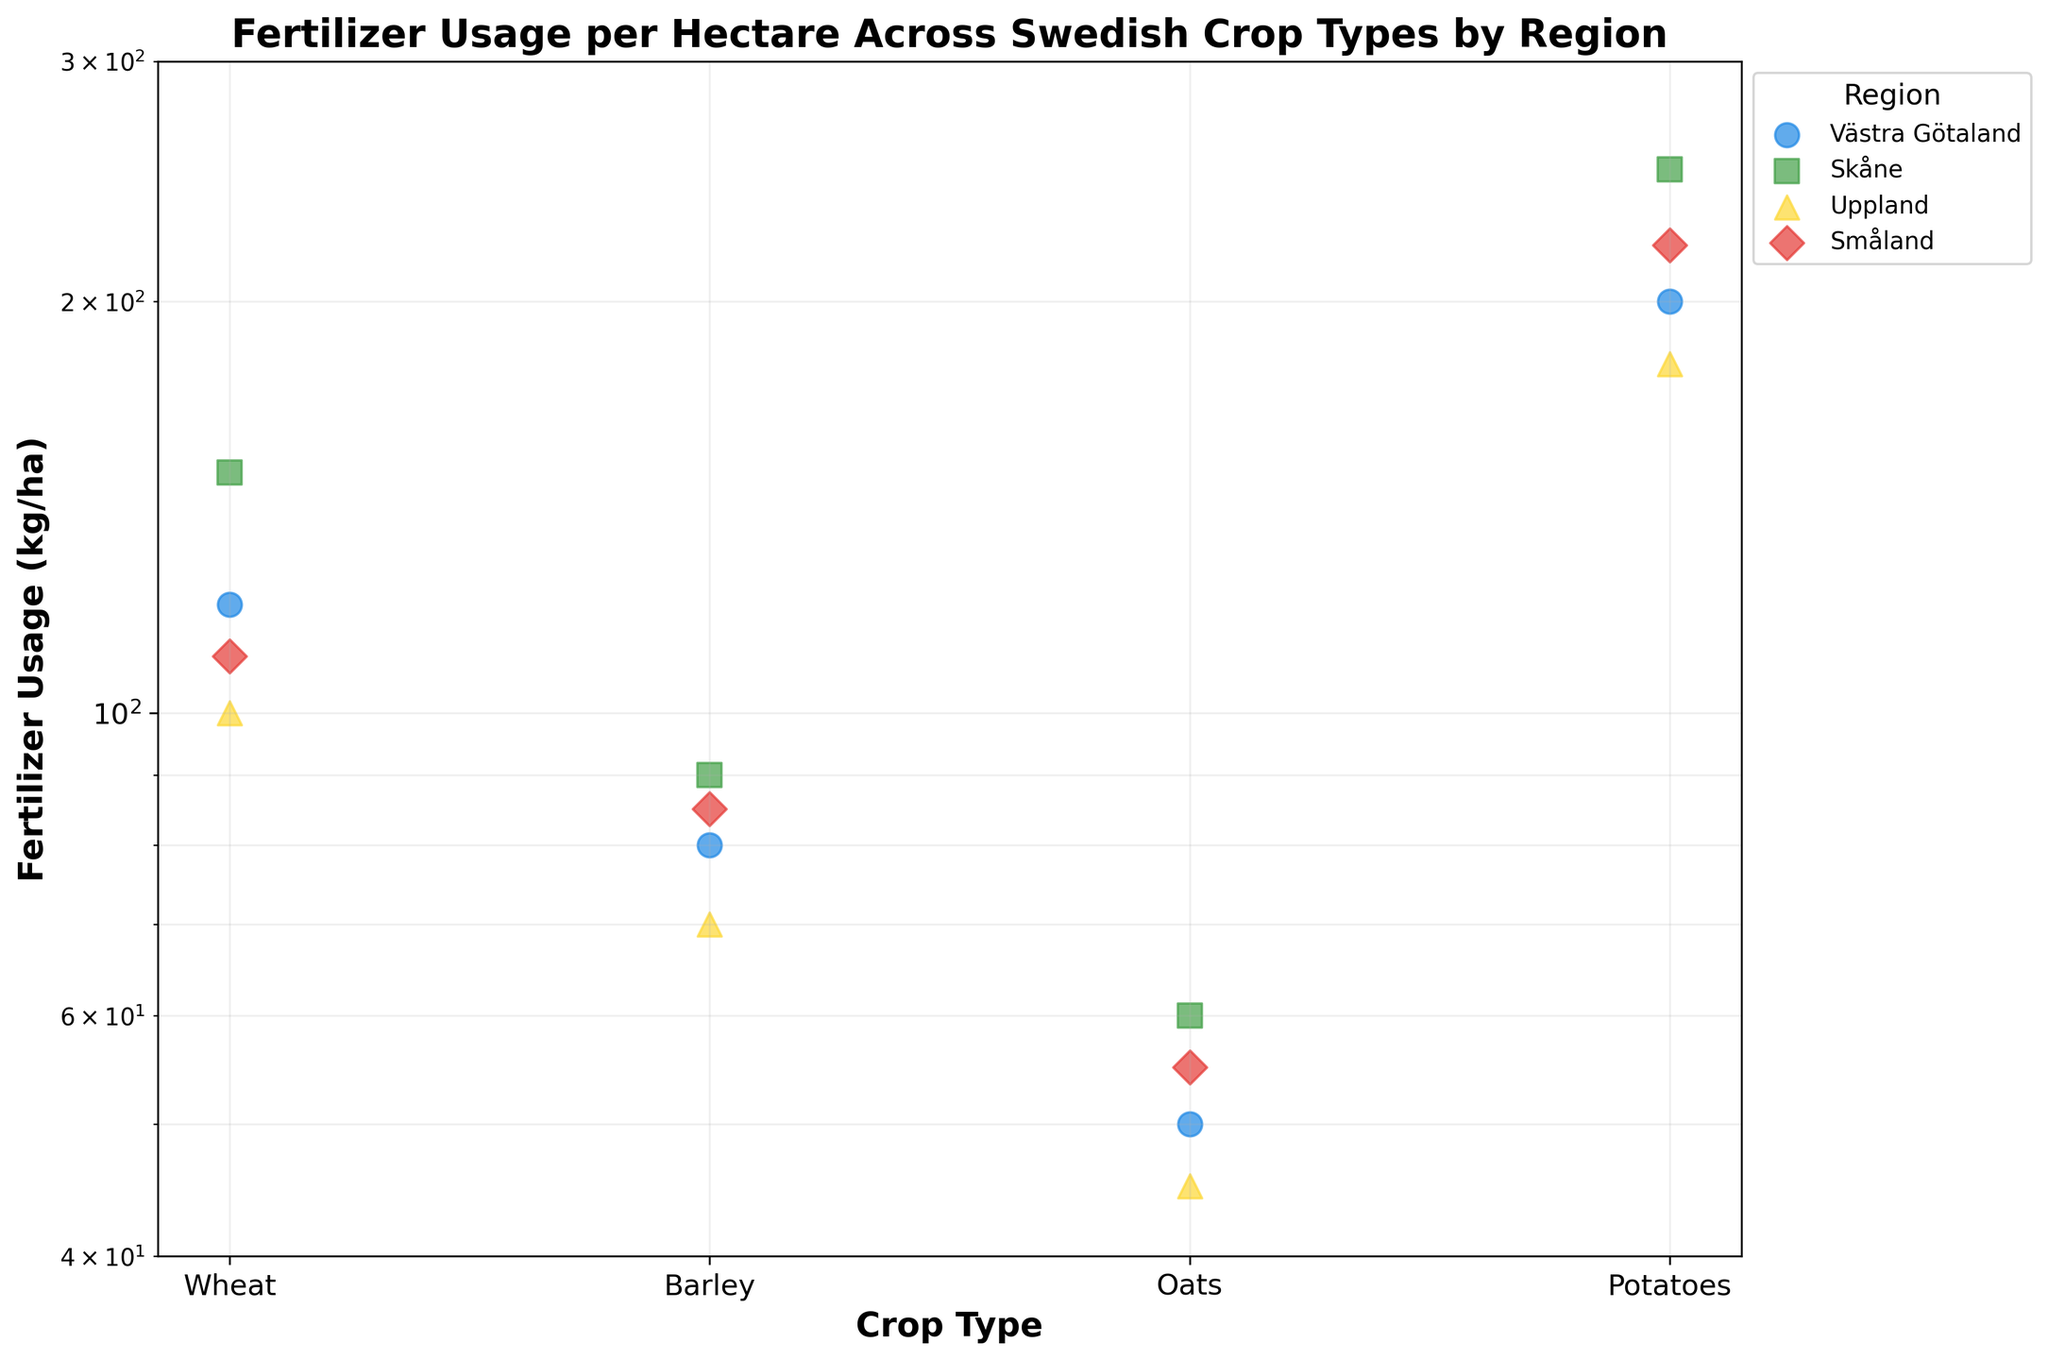What is the title of the figure? The title is usually located at the top of the figure. The text there is "Fertilizer Usage per Hectare Across Swedish Crop Types by Region".
Answer: Fertilizer Usage per Hectare Across Swedish Crop Types by Region How many regions are represented in the figure? There are distinct colors and labels in the figure legend, each corresponding to a different region. By counting them, we see there are four regions.
Answer: 4 For which crop does Skåne have the highest fertilizer usage? Look for the Skåne region (often represented by a specific color or legend marker) and identify the crop with the highest y-value for fertilizer usage. For Skåne, Potatoes have the highest fertilizer usage at 250 kg/ha.
Answer: Potatoes Which region has the highest fertilizer usage for Wheat? First, identify the data points for Wheat, then compare the regions. Skåne has the highest usage with 150 kg/ha.
Answer: Skåne What is the range of fertilizer usage for Barley across all regions? Check the fertilizer usage values for Barley in all regions: Västra Götaland (80 kg/ha), Skåne (90 kg/ha), Uppland (70 kg/ha), and Småland (85 kg/ha). The range is the difference between the highest and lowest values (90 - 70 kg/ha).
Answer: 20 kg/ha Which region consistently uses the least fertilizer across all crop types? For each crop type, identify the region with the lowest value and note the region that appears most frequently in these cases. Uppland has the lowest values for Wheat (100 kg/ha), Barley (70 kg/ha), and Oats (45 kg/ha), appearing most frequently.
Answer: Uppland Compare the fertilizer usage for Potatoes in Västra Götaland and Småland. Which region uses more fertilizer and by how much? Check the values for Potatoes in Västra Götaland (200 kg/ha) and Småland (220 kg/ha). Småland uses more by a difference of 20 kg/ha (220 - 200).
Answer: Småland by 20 kg/ha Which crop type demonstrates the widest range of fertilizer usage across regions? Calculate the range for each crop by finding the difference between the highest and lowest values among regions. Potatoes display the widest range: Västra Götaland (200 kg/ha) to Skåne (250 kg/ha).
Answer: Potatoes What is the geometric mean of the fertilizer usage for Oats in all regions? The geometric mean is calculated by multiplying all values and taking the n-th root (where n is the number of values). For Oats: 50, 60, 45, 55 --> Geometric mean = (50 * 60 * 45 * 55)^(1/4) ≈ 52.09 kg/ha.
Answer: ~52.09 kg/ha Which region has the smallest variation in fertilizer usage across all crop types? Determine the range for each region by finding the difference between their highest and lowest values. Västra Götaland’s range is 200 - 50 = 150 kg/ha, Skåne’s is 250 - 60 = 190 kg/ha, Uppland’s is 180 - 45 = 135 kg/ha, Småland’s is 220 - 55 = 165 kg/ha. Uppland has the smallest range.
Answer: Uppland 